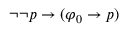Convert formula to latex. <formula><loc_0><loc_0><loc_500><loc_500>\neg \neg p \to ( \varphi _ { 0 } \to p )</formula> 